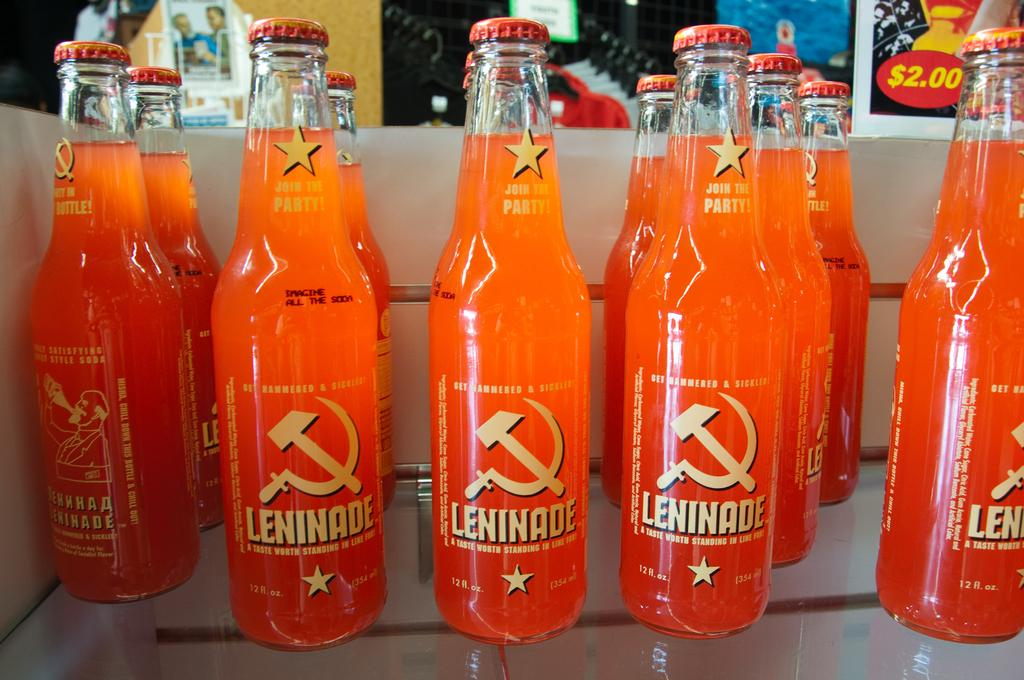What objects can be seen in the image? There are bottles in the image. What can be seen in the background of the image? There are wall posters in the background of the image. What type of bell can be heard ringing in the image? There is no bell present in the image, and therefore no sound can be heard. 